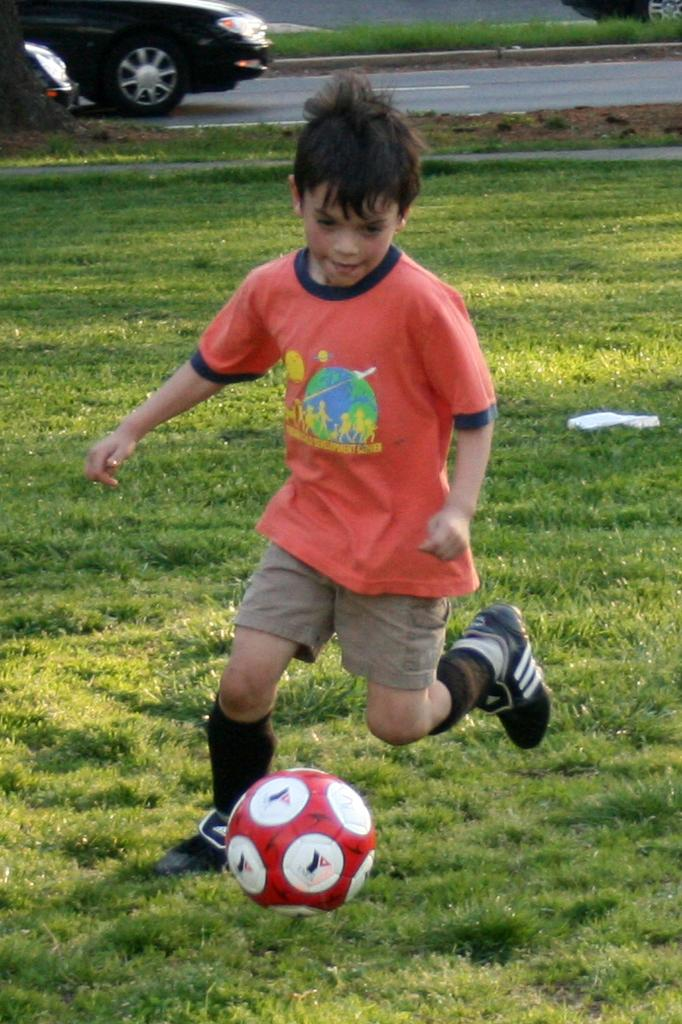What is the boy in the image doing? The boy is running on the ground in the image. What object is in front of the boy? There is a ball in front of the boy. What else can be seen in the background of the image? A car is traveling on the ground in the background. What type of surface is the boy running on? The boy is running on grass, which is visible in the image. What type of form is the boy filling out while running in the image? There is no form present in the image; the boy is simply running on the grass. 